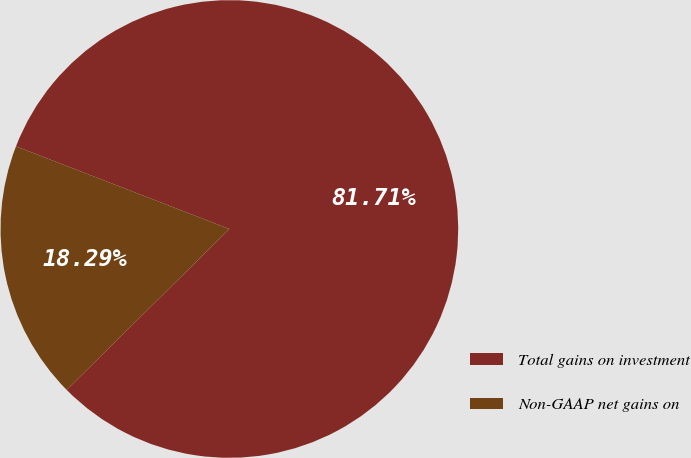Convert chart to OTSL. <chart><loc_0><loc_0><loc_500><loc_500><pie_chart><fcel>Total gains on investment<fcel>Non-GAAP net gains on<nl><fcel>81.71%<fcel>18.29%<nl></chart> 